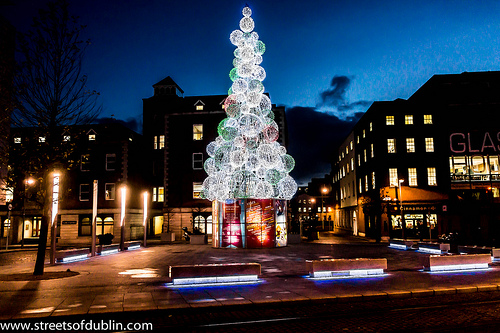<image>
Can you confirm if the tree is in front of the building? Yes. The tree is positioned in front of the building, appearing closer to the camera viewpoint. Where is the building in relation to the street? Is it above the street? No. The building is not positioned above the street. The vertical arrangement shows a different relationship. 